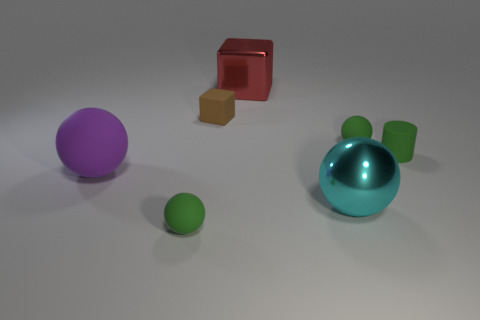Add 2 big gray matte balls. How many objects exist? 9 Subtract all cylinders. How many objects are left? 6 Subtract 0 cyan cylinders. How many objects are left? 7 Subtract all cyan rubber cubes. Subtract all metallic spheres. How many objects are left? 6 Add 3 green rubber objects. How many green rubber objects are left? 6 Add 5 red cubes. How many red cubes exist? 6 